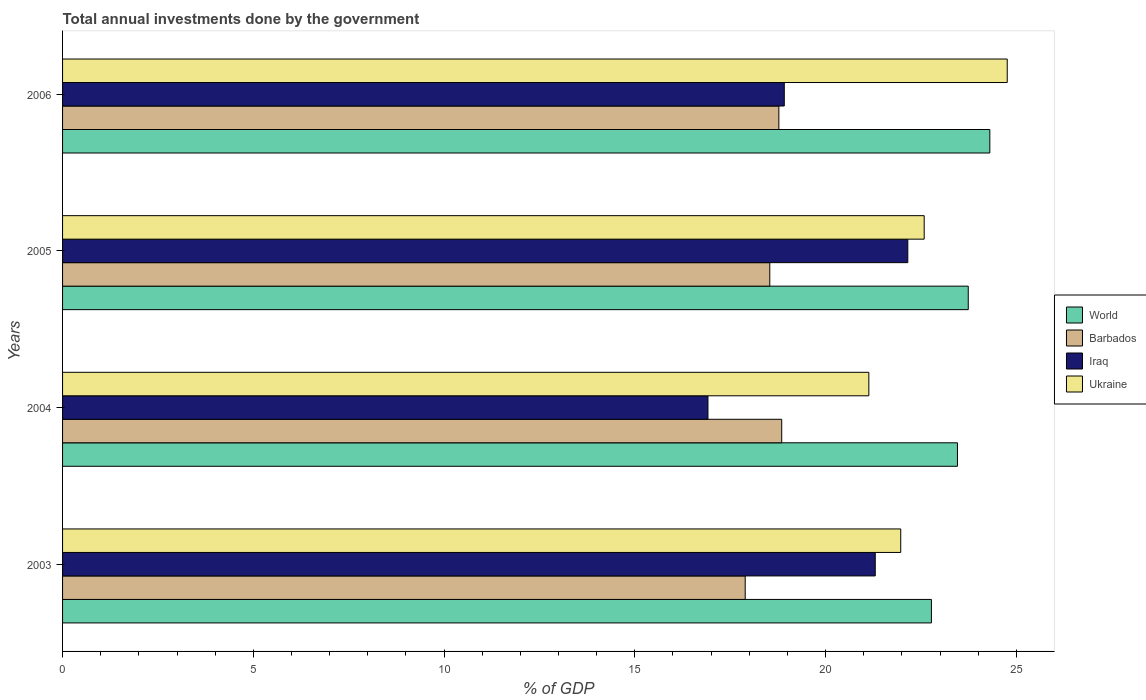Are the number of bars per tick equal to the number of legend labels?
Your answer should be very brief. Yes. Are the number of bars on each tick of the Y-axis equal?
Offer a terse response. Yes. What is the label of the 1st group of bars from the top?
Ensure brevity in your answer.  2006. What is the total annual investments done by the government in Iraq in 2005?
Provide a short and direct response. 22.16. Across all years, what is the maximum total annual investments done by the government in Barbados?
Ensure brevity in your answer.  18.85. Across all years, what is the minimum total annual investments done by the government in Barbados?
Your answer should be very brief. 17.89. What is the total total annual investments done by the government in World in the graph?
Make the answer very short. 94.28. What is the difference between the total annual investments done by the government in Ukraine in 2004 and that in 2006?
Provide a succinct answer. -3.63. What is the difference between the total annual investments done by the government in Ukraine in 2006 and the total annual investments done by the government in Iraq in 2005?
Offer a very short reply. 2.61. What is the average total annual investments done by the government in World per year?
Your answer should be compact. 23.57. In the year 2006, what is the difference between the total annual investments done by the government in World and total annual investments done by the government in Ukraine?
Give a very brief answer. -0.46. What is the ratio of the total annual investments done by the government in Barbados in 2003 to that in 2004?
Give a very brief answer. 0.95. What is the difference between the highest and the second highest total annual investments done by the government in Barbados?
Provide a succinct answer. 0.08. What is the difference between the highest and the lowest total annual investments done by the government in Barbados?
Offer a very short reply. 0.96. In how many years, is the total annual investments done by the government in World greater than the average total annual investments done by the government in World taken over all years?
Make the answer very short. 2. Is the sum of the total annual investments done by the government in World in 2004 and 2005 greater than the maximum total annual investments done by the government in Ukraine across all years?
Provide a succinct answer. Yes. Is it the case that in every year, the sum of the total annual investments done by the government in Iraq and total annual investments done by the government in Ukraine is greater than the sum of total annual investments done by the government in World and total annual investments done by the government in Barbados?
Give a very brief answer. No. What does the 3rd bar from the top in 2003 represents?
Offer a very short reply. Barbados. What does the 4th bar from the bottom in 2006 represents?
Ensure brevity in your answer.  Ukraine. How many bars are there?
Your response must be concise. 16. Are all the bars in the graph horizontal?
Ensure brevity in your answer.  Yes. What is the difference between two consecutive major ticks on the X-axis?
Provide a succinct answer. 5. Where does the legend appear in the graph?
Your answer should be very brief. Center right. What is the title of the graph?
Your response must be concise. Total annual investments done by the government. What is the label or title of the X-axis?
Offer a terse response. % of GDP. What is the label or title of the Y-axis?
Keep it short and to the point. Years. What is the % of GDP in World in 2003?
Offer a terse response. 22.77. What is the % of GDP in Barbados in 2003?
Offer a very short reply. 17.89. What is the % of GDP of Iraq in 2003?
Your answer should be very brief. 21.3. What is the % of GDP in Ukraine in 2003?
Provide a short and direct response. 21.97. What is the % of GDP of World in 2004?
Offer a terse response. 23.46. What is the % of GDP in Barbados in 2004?
Offer a terse response. 18.85. What is the % of GDP of Iraq in 2004?
Make the answer very short. 16.92. What is the % of GDP of Ukraine in 2004?
Provide a succinct answer. 21.13. What is the % of GDP of World in 2005?
Provide a succinct answer. 23.74. What is the % of GDP of Barbados in 2005?
Offer a terse response. 18.54. What is the % of GDP in Iraq in 2005?
Provide a short and direct response. 22.16. What is the % of GDP of Ukraine in 2005?
Offer a very short reply. 22.58. What is the % of GDP of World in 2006?
Your response must be concise. 24.31. What is the % of GDP in Barbados in 2006?
Offer a very short reply. 18.78. What is the % of GDP of Iraq in 2006?
Offer a very short reply. 18.92. What is the % of GDP in Ukraine in 2006?
Your response must be concise. 24.76. Across all years, what is the maximum % of GDP of World?
Offer a terse response. 24.31. Across all years, what is the maximum % of GDP of Barbados?
Your response must be concise. 18.85. Across all years, what is the maximum % of GDP in Iraq?
Your answer should be compact. 22.16. Across all years, what is the maximum % of GDP in Ukraine?
Provide a short and direct response. 24.76. Across all years, what is the minimum % of GDP in World?
Provide a succinct answer. 22.77. Across all years, what is the minimum % of GDP in Barbados?
Provide a succinct answer. 17.89. Across all years, what is the minimum % of GDP of Iraq?
Provide a succinct answer. 16.92. Across all years, what is the minimum % of GDP in Ukraine?
Ensure brevity in your answer.  21.13. What is the total % of GDP of World in the graph?
Your response must be concise. 94.28. What is the total % of GDP in Barbados in the graph?
Ensure brevity in your answer.  74.06. What is the total % of GDP of Iraq in the graph?
Your response must be concise. 79.29. What is the total % of GDP of Ukraine in the graph?
Keep it short and to the point. 90.45. What is the difference between the % of GDP of World in 2003 and that in 2004?
Make the answer very short. -0.68. What is the difference between the % of GDP in Barbados in 2003 and that in 2004?
Provide a short and direct response. -0.96. What is the difference between the % of GDP of Iraq in 2003 and that in 2004?
Give a very brief answer. 4.38. What is the difference between the % of GDP in Ukraine in 2003 and that in 2004?
Your answer should be compact. 0.84. What is the difference between the % of GDP in World in 2003 and that in 2005?
Make the answer very short. -0.97. What is the difference between the % of GDP of Barbados in 2003 and that in 2005?
Your answer should be very brief. -0.64. What is the difference between the % of GDP in Iraq in 2003 and that in 2005?
Your answer should be compact. -0.85. What is the difference between the % of GDP in Ukraine in 2003 and that in 2005?
Offer a terse response. -0.61. What is the difference between the % of GDP of World in 2003 and that in 2006?
Your response must be concise. -1.53. What is the difference between the % of GDP of Barbados in 2003 and that in 2006?
Provide a succinct answer. -0.88. What is the difference between the % of GDP in Iraq in 2003 and that in 2006?
Ensure brevity in your answer.  2.38. What is the difference between the % of GDP in Ukraine in 2003 and that in 2006?
Keep it short and to the point. -2.79. What is the difference between the % of GDP in World in 2004 and that in 2005?
Provide a succinct answer. -0.28. What is the difference between the % of GDP in Barbados in 2004 and that in 2005?
Your answer should be very brief. 0.31. What is the difference between the % of GDP in Iraq in 2004 and that in 2005?
Make the answer very short. -5.24. What is the difference between the % of GDP of Ukraine in 2004 and that in 2005?
Offer a terse response. -1.45. What is the difference between the % of GDP of World in 2004 and that in 2006?
Ensure brevity in your answer.  -0.85. What is the difference between the % of GDP in Barbados in 2004 and that in 2006?
Make the answer very short. 0.08. What is the difference between the % of GDP of Iraq in 2004 and that in 2006?
Offer a very short reply. -2. What is the difference between the % of GDP in Ukraine in 2004 and that in 2006?
Offer a terse response. -3.63. What is the difference between the % of GDP in World in 2005 and that in 2006?
Provide a short and direct response. -0.57. What is the difference between the % of GDP of Barbados in 2005 and that in 2006?
Provide a succinct answer. -0.24. What is the difference between the % of GDP in Iraq in 2005 and that in 2006?
Keep it short and to the point. 3.24. What is the difference between the % of GDP in Ukraine in 2005 and that in 2006?
Ensure brevity in your answer.  -2.18. What is the difference between the % of GDP of World in 2003 and the % of GDP of Barbados in 2004?
Make the answer very short. 3.92. What is the difference between the % of GDP in World in 2003 and the % of GDP in Iraq in 2004?
Provide a short and direct response. 5.86. What is the difference between the % of GDP of World in 2003 and the % of GDP of Ukraine in 2004?
Your response must be concise. 1.64. What is the difference between the % of GDP in Barbados in 2003 and the % of GDP in Iraq in 2004?
Your answer should be very brief. 0.98. What is the difference between the % of GDP in Barbados in 2003 and the % of GDP in Ukraine in 2004?
Your answer should be very brief. -3.24. What is the difference between the % of GDP of Iraq in 2003 and the % of GDP of Ukraine in 2004?
Offer a very short reply. 0.17. What is the difference between the % of GDP in World in 2003 and the % of GDP in Barbados in 2005?
Make the answer very short. 4.24. What is the difference between the % of GDP of World in 2003 and the % of GDP of Iraq in 2005?
Keep it short and to the point. 0.62. What is the difference between the % of GDP of World in 2003 and the % of GDP of Ukraine in 2005?
Provide a succinct answer. 0.19. What is the difference between the % of GDP of Barbados in 2003 and the % of GDP of Iraq in 2005?
Your answer should be compact. -4.26. What is the difference between the % of GDP of Barbados in 2003 and the % of GDP of Ukraine in 2005?
Your answer should be compact. -4.69. What is the difference between the % of GDP of Iraq in 2003 and the % of GDP of Ukraine in 2005?
Your answer should be very brief. -1.28. What is the difference between the % of GDP in World in 2003 and the % of GDP in Barbados in 2006?
Provide a succinct answer. 4. What is the difference between the % of GDP in World in 2003 and the % of GDP in Iraq in 2006?
Ensure brevity in your answer.  3.86. What is the difference between the % of GDP of World in 2003 and the % of GDP of Ukraine in 2006?
Provide a succinct answer. -1.99. What is the difference between the % of GDP of Barbados in 2003 and the % of GDP of Iraq in 2006?
Offer a very short reply. -1.02. What is the difference between the % of GDP of Barbados in 2003 and the % of GDP of Ukraine in 2006?
Offer a very short reply. -6.87. What is the difference between the % of GDP in Iraq in 2003 and the % of GDP in Ukraine in 2006?
Your answer should be compact. -3.46. What is the difference between the % of GDP of World in 2004 and the % of GDP of Barbados in 2005?
Ensure brevity in your answer.  4.92. What is the difference between the % of GDP in World in 2004 and the % of GDP in Iraq in 2005?
Your answer should be very brief. 1.3. What is the difference between the % of GDP in World in 2004 and the % of GDP in Ukraine in 2005?
Offer a terse response. 0.87. What is the difference between the % of GDP of Barbados in 2004 and the % of GDP of Iraq in 2005?
Provide a short and direct response. -3.3. What is the difference between the % of GDP in Barbados in 2004 and the % of GDP in Ukraine in 2005?
Provide a succinct answer. -3.73. What is the difference between the % of GDP of Iraq in 2004 and the % of GDP of Ukraine in 2005?
Provide a succinct answer. -5.67. What is the difference between the % of GDP in World in 2004 and the % of GDP in Barbados in 2006?
Offer a terse response. 4.68. What is the difference between the % of GDP of World in 2004 and the % of GDP of Iraq in 2006?
Your response must be concise. 4.54. What is the difference between the % of GDP of World in 2004 and the % of GDP of Ukraine in 2006?
Provide a succinct answer. -1.3. What is the difference between the % of GDP in Barbados in 2004 and the % of GDP in Iraq in 2006?
Give a very brief answer. -0.07. What is the difference between the % of GDP in Barbados in 2004 and the % of GDP in Ukraine in 2006?
Your answer should be compact. -5.91. What is the difference between the % of GDP in Iraq in 2004 and the % of GDP in Ukraine in 2006?
Provide a succinct answer. -7.84. What is the difference between the % of GDP of World in 2005 and the % of GDP of Barbados in 2006?
Give a very brief answer. 4.96. What is the difference between the % of GDP in World in 2005 and the % of GDP in Iraq in 2006?
Keep it short and to the point. 4.82. What is the difference between the % of GDP of World in 2005 and the % of GDP of Ukraine in 2006?
Ensure brevity in your answer.  -1.02. What is the difference between the % of GDP in Barbados in 2005 and the % of GDP in Iraq in 2006?
Offer a very short reply. -0.38. What is the difference between the % of GDP in Barbados in 2005 and the % of GDP in Ukraine in 2006?
Your answer should be compact. -6.22. What is the difference between the % of GDP of Iraq in 2005 and the % of GDP of Ukraine in 2006?
Your response must be concise. -2.61. What is the average % of GDP in World per year?
Give a very brief answer. 23.57. What is the average % of GDP in Barbados per year?
Give a very brief answer. 18.51. What is the average % of GDP of Iraq per year?
Provide a succinct answer. 19.82. What is the average % of GDP of Ukraine per year?
Your answer should be very brief. 22.61. In the year 2003, what is the difference between the % of GDP of World and % of GDP of Barbados?
Your answer should be very brief. 4.88. In the year 2003, what is the difference between the % of GDP in World and % of GDP in Iraq?
Your response must be concise. 1.47. In the year 2003, what is the difference between the % of GDP in World and % of GDP in Ukraine?
Your answer should be compact. 0.8. In the year 2003, what is the difference between the % of GDP in Barbados and % of GDP in Iraq?
Offer a very short reply. -3.41. In the year 2003, what is the difference between the % of GDP of Barbados and % of GDP of Ukraine?
Offer a very short reply. -4.08. In the year 2003, what is the difference between the % of GDP in Iraq and % of GDP in Ukraine?
Keep it short and to the point. -0.67. In the year 2004, what is the difference between the % of GDP in World and % of GDP in Barbados?
Give a very brief answer. 4.61. In the year 2004, what is the difference between the % of GDP in World and % of GDP in Iraq?
Provide a succinct answer. 6.54. In the year 2004, what is the difference between the % of GDP of World and % of GDP of Ukraine?
Ensure brevity in your answer.  2.32. In the year 2004, what is the difference between the % of GDP of Barbados and % of GDP of Iraq?
Provide a succinct answer. 1.93. In the year 2004, what is the difference between the % of GDP in Barbados and % of GDP in Ukraine?
Offer a very short reply. -2.28. In the year 2004, what is the difference between the % of GDP of Iraq and % of GDP of Ukraine?
Provide a short and direct response. -4.22. In the year 2005, what is the difference between the % of GDP of World and % of GDP of Barbados?
Your answer should be very brief. 5.2. In the year 2005, what is the difference between the % of GDP in World and % of GDP in Iraq?
Your answer should be very brief. 1.58. In the year 2005, what is the difference between the % of GDP of World and % of GDP of Ukraine?
Your response must be concise. 1.15. In the year 2005, what is the difference between the % of GDP in Barbados and % of GDP in Iraq?
Provide a short and direct response. -3.62. In the year 2005, what is the difference between the % of GDP in Barbados and % of GDP in Ukraine?
Provide a short and direct response. -4.05. In the year 2005, what is the difference between the % of GDP in Iraq and % of GDP in Ukraine?
Give a very brief answer. -0.43. In the year 2006, what is the difference between the % of GDP in World and % of GDP in Barbados?
Provide a succinct answer. 5.53. In the year 2006, what is the difference between the % of GDP in World and % of GDP in Iraq?
Your response must be concise. 5.39. In the year 2006, what is the difference between the % of GDP in World and % of GDP in Ukraine?
Your answer should be compact. -0.46. In the year 2006, what is the difference between the % of GDP in Barbados and % of GDP in Iraq?
Give a very brief answer. -0.14. In the year 2006, what is the difference between the % of GDP of Barbados and % of GDP of Ukraine?
Your answer should be very brief. -5.99. In the year 2006, what is the difference between the % of GDP in Iraq and % of GDP in Ukraine?
Your answer should be very brief. -5.84. What is the ratio of the % of GDP in World in 2003 to that in 2004?
Offer a terse response. 0.97. What is the ratio of the % of GDP in Barbados in 2003 to that in 2004?
Keep it short and to the point. 0.95. What is the ratio of the % of GDP in Iraq in 2003 to that in 2004?
Your answer should be compact. 1.26. What is the ratio of the % of GDP of Ukraine in 2003 to that in 2004?
Offer a very short reply. 1.04. What is the ratio of the % of GDP in World in 2003 to that in 2005?
Your answer should be very brief. 0.96. What is the ratio of the % of GDP in Barbados in 2003 to that in 2005?
Your answer should be compact. 0.97. What is the ratio of the % of GDP of Iraq in 2003 to that in 2005?
Your answer should be very brief. 0.96. What is the ratio of the % of GDP in Ukraine in 2003 to that in 2005?
Keep it short and to the point. 0.97. What is the ratio of the % of GDP in World in 2003 to that in 2006?
Your answer should be very brief. 0.94. What is the ratio of the % of GDP of Barbados in 2003 to that in 2006?
Ensure brevity in your answer.  0.95. What is the ratio of the % of GDP of Iraq in 2003 to that in 2006?
Provide a succinct answer. 1.13. What is the ratio of the % of GDP of Ukraine in 2003 to that in 2006?
Your answer should be compact. 0.89. What is the ratio of the % of GDP in Barbados in 2004 to that in 2005?
Ensure brevity in your answer.  1.02. What is the ratio of the % of GDP in Iraq in 2004 to that in 2005?
Your answer should be compact. 0.76. What is the ratio of the % of GDP in Ukraine in 2004 to that in 2005?
Your response must be concise. 0.94. What is the ratio of the % of GDP in World in 2004 to that in 2006?
Offer a very short reply. 0.97. What is the ratio of the % of GDP of Iraq in 2004 to that in 2006?
Your answer should be very brief. 0.89. What is the ratio of the % of GDP in Ukraine in 2004 to that in 2006?
Ensure brevity in your answer.  0.85. What is the ratio of the % of GDP in World in 2005 to that in 2006?
Your answer should be very brief. 0.98. What is the ratio of the % of GDP of Barbados in 2005 to that in 2006?
Keep it short and to the point. 0.99. What is the ratio of the % of GDP of Iraq in 2005 to that in 2006?
Give a very brief answer. 1.17. What is the ratio of the % of GDP of Ukraine in 2005 to that in 2006?
Ensure brevity in your answer.  0.91. What is the difference between the highest and the second highest % of GDP of World?
Provide a short and direct response. 0.57. What is the difference between the highest and the second highest % of GDP of Barbados?
Ensure brevity in your answer.  0.08. What is the difference between the highest and the second highest % of GDP of Iraq?
Your answer should be compact. 0.85. What is the difference between the highest and the second highest % of GDP of Ukraine?
Offer a terse response. 2.18. What is the difference between the highest and the lowest % of GDP in World?
Provide a succinct answer. 1.53. What is the difference between the highest and the lowest % of GDP of Barbados?
Provide a succinct answer. 0.96. What is the difference between the highest and the lowest % of GDP of Iraq?
Your answer should be compact. 5.24. What is the difference between the highest and the lowest % of GDP in Ukraine?
Offer a very short reply. 3.63. 